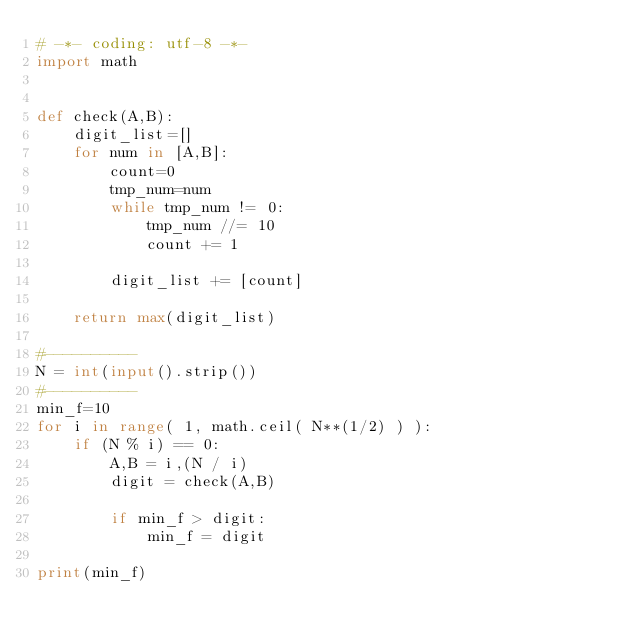Convert code to text. <code><loc_0><loc_0><loc_500><loc_500><_Python_># -*- coding: utf-8 -*-
import math


def check(A,B):
    digit_list=[]
    for num in [A,B]:
        count=0
        tmp_num=num
        while tmp_num != 0:
            tmp_num //= 10
            count += 1
        
        digit_list += [count]
    
    return max(digit_list)

#----------
N = int(input().strip())
#----------
min_f=10
for i in range( 1, math.ceil( N**(1/2) ) ):
    if (N % i) == 0:
        A,B = i,(N / i)
        digit = check(A,B)
        
        if min_f > digit:
            min_f = digit

print(min_f)
</code> 